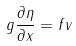Convert formula to latex. <formula><loc_0><loc_0><loc_500><loc_500>g \frac { \partial \eta } { \partial x } = f v</formula> 